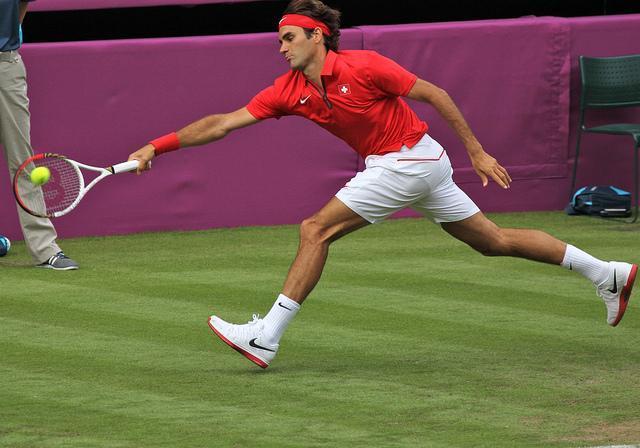How many hands are holding the racket?
Give a very brief answer. 1. How many people in the picture?
Give a very brief answer. 2. How many tennis rackets are there?
Give a very brief answer. 1. How many people can be seen?
Give a very brief answer. 2. 